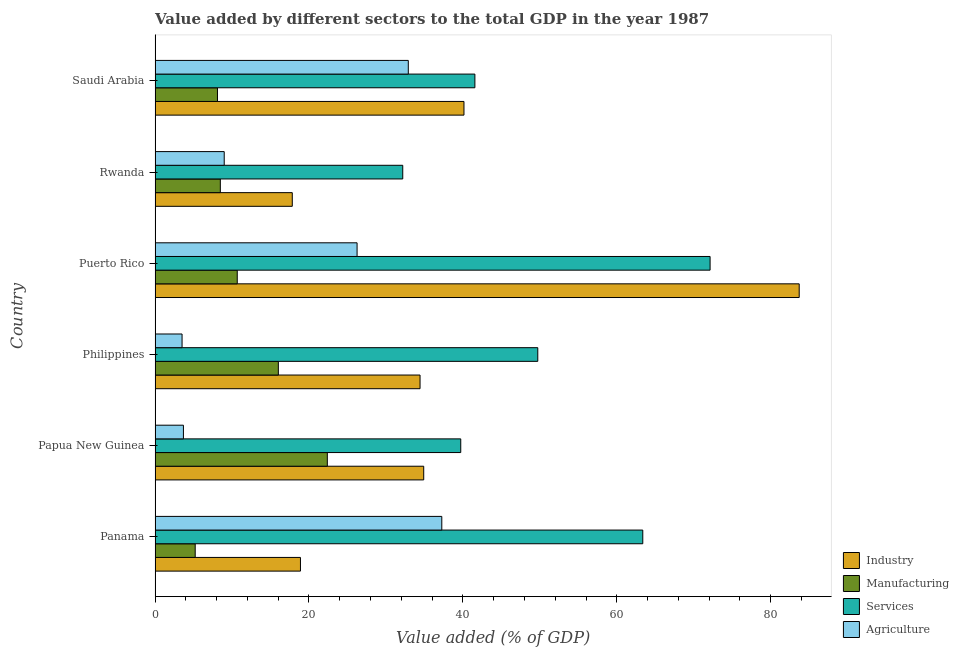How many bars are there on the 2nd tick from the top?
Provide a succinct answer. 4. How many bars are there on the 4th tick from the bottom?
Your answer should be very brief. 4. What is the label of the 3rd group of bars from the top?
Give a very brief answer. Puerto Rico. What is the value added by manufacturing sector in Philippines?
Give a very brief answer. 16.02. Across all countries, what is the maximum value added by industrial sector?
Provide a succinct answer. 83.7. Across all countries, what is the minimum value added by manufacturing sector?
Your response must be concise. 5.22. In which country was the value added by manufacturing sector maximum?
Keep it short and to the point. Papua New Guinea. In which country was the value added by manufacturing sector minimum?
Keep it short and to the point. Panama. What is the total value added by industrial sector in the graph?
Your answer should be compact. 229.91. What is the difference between the value added by services sector in Rwanda and that in Saudi Arabia?
Offer a very short reply. -9.37. What is the difference between the value added by services sector in Puerto Rico and the value added by agricultural sector in Rwanda?
Offer a terse response. 63.13. What is the average value added by manufacturing sector per country?
Give a very brief answer. 11.81. What is the difference between the value added by manufacturing sector and value added by industrial sector in Rwanda?
Provide a short and direct response. -9.35. What is the ratio of the value added by manufacturing sector in Philippines to that in Puerto Rico?
Keep it short and to the point. 1.5. Is the value added by agricultural sector in Papua New Guinea less than that in Rwanda?
Your answer should be very brief. Yes. What is the difference between the highest and the second highest value added by industrial sector?
Keep it short and to the point. 43.56. What is the difference between the highest and the lowest value added by industrial sector?
Provide a short and direct response. 65.87. Is the sum of the value added by agricultural sector in Papua New Guinea and Puerto Rico greater than the maximum value added by industrial sector across all countries?
Your response must be concise. No. Is it the case that in every country, the sum of the value added by services sector and value added by manufacturing sector is greater than the sum of value added by industrial sector and value added by agricultural sector?
Offer a very short reply. No. What does the 4th bar from the top in Philippines represents?
Offer a very short reply. Industry. What does the 4th bar from the bottom in Panama represents?
Offer a very short reply. Agriculture. How many bars are there?
Your answer should be compact. 24. Are all the bars in the graph horizontal?
Your answer should be compact. Yes. Are the values on the major ticks of X-axis written in scientific E-notation?
Ensure brevity in your answer.  No. Does the graph contain any zero values?
Keep it short and to the point. No. How many legend labels are there?
Offer a very short reply. 4. How are the legend labels stacked?
Keep it short and to the point. Vertical. What is the title of the graph?
Keep it short and to the point. Value added by different sectors to the total GDP in the year 1987. Does "Pre-primary schools" appear as one of the legend labels in the graph?
Your answer should be very brief. No. What is the label or title of the X-axis?
Provide a succinct answer. Value added (% of GDP). What is the Value added (% of GDP) of Industry in Panama?
Your answer should be compact. 18.89. What is the Value added (% of GDP) of Manufacturing in Panama?
Ensure brevity in your answer.  5.22. What is the Value added (% of GDP) in Services in Panama?
Provide a succinct answer. 63.38. What is the Value added (% of GDP) of Agriculture in Panama?
Provide a succinct answer. 37.26. What is the Value added (% of GDP) in Industry in Papua New Guinea?
Your response must be concise. 34.91. What is the Value added (% of GDP) in Manufacturing in Papua New Guinea?
Your answer should be very brief. 22.39. What is the Value added (% of GDP) of Services in Papua New Guinea?
Your answer should be very brief. 39.72. What is the Value added (% of GDP) of Agriculture in Papua New Guinea?
Offer a very short reply. 3.69. What is the Value added (% of GDP) in Industry in Philippines?
Keep it short and to the point. 34.43. What is the Value added (% of GDP) in Manufacturing in Philippines?
Offer a very short reply. 16.02. What is the Value added (% of GDP) of Services in Philippines?
Make the answer very short. 49.73. What is the Value added (% of GDP) of Agriculture in Philippines?
Offer a very short reply. 3.51. What is the Value added (% of GDP) in Industry in Puerto Rico?
Your answer should be compact. 83.7. What is the Value added (% of GDP) in Manufacturing in Puerto Rico?
Ensure brevity in your answer.  10.68. What is the Value added (% of GDP) in Services in Puerto Rico?
Keep it short and to the point. 72.12. What is the Value added (% of GDP) in Agriculture in Puerto Rico?
Offer a very short reply. 26.25. What is the Value added (% of GDP) of Industry in Rwanda?
Your answer should be very brief. 17.83. What is the Value added (% of GDP) of Manufacturing in Rwanda?
Offer a terse response. 8.48. What is the Value added (% of GDP) of Services in Rwanda?
Give a very brief answer. 32.18. What is the Value added (% of GDP) of Agriculture in Rwanda?
Make the answer very short. 8.99. What is the Value added (% of GDP) of Industry in Saudi Arabia?
Keep it short and to the point. 40.14. What is the Value added (% of GDP) of Manufacturing in Saudi Arabia?
Give a very brief answer. 8.11. What is the Value added (% of GDP) of Services in Saudi Arabia?
Provide a short and direct response. 41.56. What is the Value added (% of GDP) of Agriculture in Saudi Arabia?
Make the answer very short. 32.91. Across all countries, what is the maximum Value added (% of GDP) in Industry?
Your answer should be very brief. 83.7. Across all countries, what is the maximum Value added (% of GDP) in Manufacturing?
Keep it short and to the point. 22.39. Across all countries, what is the maximum Value added (% of GDP) in Services?
Your response must be concise. 72.12. Across all countries, what is the maximum Value added (% of GDP) in Agriculture?
Give a very brief answer. 37.26. Across all countries, what is the minimum Value added (% of GDP) in Industry?
Offer a very short reply. 17.83. Across all countries, what is the minimum Value added (% of GDP) of Manufacturing?
Your answer should be compact. 5.22. Across all countries, what is the minimum Value added (% of GDP) of Services?
Give a very brief answer. 32.18. Across all countries, what is the minimum Value added (% of GDP) in Agriculture?
Offer a terse response. 3.51. What is the total Value added (% of GDP) of Industry in the graph?
Your response must be concise. 229.91. What is the total Value added (% of GDP) in Manufacturing in the graph?
Offer a terse response. 70.89. What is the total Value added (% of GDP) of Services in the graph?
Ensure brevity in your answer.  298.69. What is the total Value added (% of GDP) in Agriculture in the graph?
Your answer should be compact. 112.6. What is the difference between the Value added (% of GDP) in Industry in Panama and that in Papua New Guinea?
Give a very brief answer. -16.02. What is the difference between the Value added (% of GDP) of Manufacturing in Panama and that in Papua New Guinea?
Give a very brief answer. -17.17. What is the difference between the Value added (% of GDP) in Services in Panama and that in Papua New Guinea?
Offer a terse response. 23.65. What is the difference between the Value added (% of GDP) in Agriculture in Panama and that in Papua New Guinea?
Give a very brief answer. 33.57. What is the difference between the Value added (% of GDP) in Industry in Panama and that in Philippines?
Make the answer very short. -15.54. What is the difference between the Value added (% of GDP) of Manufacturing in Panama and that in Philippines?
Provide a short and direct response. -10.8. What is the difference between the Value added (% of GDP) in Services in Panama and that in Philippines?
Your response must be concise. 13.64. What is the difference between the Value added (% of GDP) of Agriculture in Panama and that in Philippines?
Your answer should be compact. 33.75. What is the difference between the Value added (% of GDP) in Industry in Panama and that in Puerto Rico?
Your answer should be compact. -64.81. What is the difference between the Value added (% of GDP) in Manufacturing in Panama and that in Puerto Rico?
Offer a very short reply. -5.46. What is the difference between the Value added (% of GDP) in Services in Panama and that in Puerto Rico?
Your response must be concise. -8.75. What is the difference between the Value added (% of GDP) of Agriculture in Panama and that in Puerto Rico?
Provide a succinct answer. 11.01. What is the difference between the Value added (% of GDP) in Industry in Panama and that in Rwanda?
Give a very brief answer. 1.06. What is the difference between the Value added (% of GDP) in Manufacturing in Panama and that in Rwanda?
Offer a very short reply. -3.26. What is the difference between the Value added (% of GDP) of Services in Panama and that in Rwanda?
Offer a very short reply. 31.19. What is the difference between the Value added (% of GDP) of Agriculture in Panama and that in Rwanda?
Your response must be concise. 28.27. What is the difference between the Value added (% of GDP) of Industry in Panama and that in Saudi Arabia?
Keep it short and to the point. -21.25. What is the difference between the Value added (% of GDP) in Manufacturing in Panama and that in Saudi Arabia?
Offer a very short reply. -2.89. What is the difference between the Value added (% of GDP) in Services in Panama and that in Saudi Arabia?
Give a very brief answer. 21.82. What is the difference between the Value added (% of GDP) in Agriculture in Panama and that in Saudi Arabia?
Provide a short and direct response. 4.35. What is the difference between the Value added (% of GDP) of Industry in Papua New Guinea and that in Philippines?
Offer a terse response. 0.48. What is the difference between the Value added (% of GDP) in Manufacturing in Papua New Guinea and that in Philippines?
Offer a terse response. 6.37. What is the difference between the Value added (% of GDP) of Services in Papua New Guinea and that in Philippines?
Offer a very short reply. -10.01. What is the difference between the Value added (% of GDP) in Agriculture in Papua New Guinea and that in Philippines?
Keep it short and to the point. 0.18. What is the difference between the Value added (% of GDP) of Industry in Papua New Guinea and that in Puerto Rico?
Give a very brief answer. -48.79. What is the difference between the Value added (% of GDP) of Manufacturing in Papua New Guinea and that in Puerto Rico?
Offer a terse response. 11.71. What is the difference between the Value added (% of GDP) of Services in Papua New Guinea and that in Puerto Rico?
Keep it short and to the point. -32.4. What is the difference between the Value added (% of GDP) in Agriculture in Papua New Guinea and that in Puerto Rico?
Offer a terse response. -22.56. What is the difference between the Value added (% of GDP) in Industry in Papua New Guinea and that in Rwanda?
Provide a short and direct response. 17.08. What is the difference between the Value added (% of GDP) of Manufacturing in Papua New Guinea and that in Rwanda?
Your answer should be compact. 13.9. What is the difference between the Value added (% of GDP) of Services in Papua New Guinea and that in Rwanda?
Offer a terse response. 7.54. What is the difference between the Value added (% of GDP) in Agriculture in Papua New Guinea and that in Rwanda?
Your answer should be compact. -5.3. What is the difference between the Value added (% of GDP) of Industry in Papua New Guinea and that in Saudi Arabia?
Your response must be concise. -5.23. What is the difference between the Value added (% of GDP) of Manufacturing in Papua New Guinea and that in Saudi Arabia?
Give a very brief answer. 14.27. What is the difference between the Value added (% of GDP) in Services in Papua New Guinea and that in Saudi Arabia?
Provide a short and direct response. -1.84. What is the difference between the Value added (% of GDP) in Agriculture in Papua New Guinea and that in Saudi Arabia?
Offer a terse response. -29.22. What is the difference between the Value added (% of GDP) of Industry in Philippines and that in Puerto Rico?
Your response must be concise. -49.27. What is the difference between the Value added (% of GDP) of Manufacturing in Philippines and that in Puerto Rico?
Ensure brevity in your answer.  5.34. What is the difference between the Value added (% of GDP) of Services in Philippines and that in Puerto Rico?
Your answer should be compact. -22.39. What is the difference between the Value added (% of GDP) in Agriculture in Philippines and that in Puerto Rico?
Give a very brief answer. -22.74. What is the difference between the Value added (% of GDP) of Industry in Philippines and that in Rwanda?
Make the answer very short. 16.6. What is the difference between the Value added (% of GDP) in Manufacturing in Philippines and that in Rwanda?
Make the answer very short. 7.54. What is the difference between the Value added (% of GDP) in Services in Philippines and that in Rwanda?
Make the answer very short. 17.55. What is the difference between the Value added (% of GDP) of Agriculture in Philippines and that in Rwanda?
Your response must be concise. -5.48. What is the difference between the Value added (% of GDP) in Industry in Philippines and that in Saudi Arabia?
Provide a short and direct response. -5.71. What is the difference between the Value added (% of GDP) in Manufacturing in Philippines and that in Saudi Arabia?
Keep it short and to the point. 7.91. What is the difference between the Value added (% of GDP) in Services in Philippines and that in Saudi Arabia?
Offer a terse response. 8.17. What is the difference between the Value added (% of GDP) in Agriculture in Philippines and that in Saudi Arabia?
Make the answer very short. -29.4. What is the difference between the Value added (% of GDP) in Industry in Puerto Rico and that in Rwanda?
Provide a succinct answer. 65.87. What is the difference between the Value added (% of GDP) in Manufacturing in Puerto Rico and that in Rwanda?
Provide a succinct answer. 2.2. What is the difference between the Value added (% of GDP) of Services in Puerto Rico and that in Rwanda?
Your answer should be very brief. 39.94. What is the difference between the Value added (% of GDP) of Agriculture in Puerto Rico and that in Rwanda?
Make the answer very short. 17.26. What is the difference between the Value added (% of GDP) in Industry in Puerto Rico and that in Saudi Arabia?
Give a very brief answer. 43.56. What is the difference between the Value added (% of GDP) in Manufacturing in Puerto Rico and that in Saudi Arabia?
Provide a short and direct response. 2.57. What is the difference between the Value added (% of GDP) in Services in Puerto Rico and that in Saudi Arabia?
Offer a terse response. 30.56. What is the difference between the Value added (% of GDP) of Agriculture in Puerto Rico and that in Saudi Arabia?
Offer a very short reply. -6.66. What is the difference between the Value added (% of GDP) in Industry in Rwanda and that in Saudi Arabia?
Provide a short and direct response. -22.31. What is the difference between the Value added (% of GDP) in Manufacturing in Rwanda and that in Saudi Arabia?
Make the answer very short. 0.37. What is the difference between the Value added (% of GDP) in Services in Rwanda and that in Saudi Arabia?
Offer a terse response. -9.37. What is the difference between the Value added (% of GDP) of Agriculture in Rwanda and that in Saudi Arabia?
Provide a short and direct response. -23.92. What is the difference between the Value added (% of GDP) of Industry in Panama and the Value added (% of GDP) of Manufacturing in Papua New Guinea?
Provide a short and direct response. -3.49. What is the difference between the Value added (% of GDP) in Industry in Panama and the Value added (% of GDP) in Services in Papua New Guinea?
Your answer should be compact. -20.83. What is the difference between the Value added (% of GDP) of Industry in Panama and the Value added (% of GDP) of Agriculture in Papua New Guinea?
Offer a very short reply. 15.21. What is the difference between the Value added (% of GDP) of Manufacturing in Panama and the Value added (% of GDP) of Services in Papua New Guinea?
Ensure brevity in your answer.  -34.51. What is the difference between the Value added (% of GDP) of Manufacturing in Panama and the Value added (% of GDP) of Agriculture in Papua New Guinea?
Ensure brevity in your answer.  1.53. What is the difference between the Value added (% of GDP) of Services in Panama and the Value added (% of GDP) of Agriculture in Papua New Guinea?
Ensure brevity in your answer.  59.69. What is the difference between the Value added (% of GDP) of Industry in Panama and the Value added (% of GDP) of Manufacturing in Philippines?
Provide a short and direct response. 2.87. What is the difference between the Value added (% of GDP) in Industry in Panama and the Value added (% of GDP) in Services in Philippines?
Your response must be concise. -30.84. What is the difference between the Value added (% of GDP) of Industry in Panama and the Value added (% of GDP) of Agriculture in Philippines?
Keep it short and to the point. 15.38. What is the difference between the Value added (% of GDP) of Manufacturing in Panama and the Value added (% of GDP) of Services in Philippines?
Make the answer very short. -44.52. What is the difference between the Value added (% of GDP) in Manufacturing in Panama and the Value added (% of GDP) in Agriculture in Philippines?
Your answer should be very brief. 1.71. What is the difference between the Value added (% of GDP) of Services in Panama and the Value added (% of GDP) of Agriculture in Philippines?
Offer a terse response. 59.87. What is the difference between the Value added (% of GDP) of Industry in Panama and the Value added (% of GDP) of Manufacturing in Puerto Rico?
Offer a very short reply. 8.21. What is the difference between the Value added (% of GDP) in Industry in Panama and the Value added (% of GDP) in Services in Puerto Rico?
Keep it short and to the point. -53.23. What is the difference between the Value added (% of GDP) in Industry in Panama and the Value added (% of GDP) in Agriculture in Puerto Rico?
Keep it short and to the point. -7.36. What is the difference between the Value added (% of GDP) in Manufacturing in Panama and the Value added (% of GDP) in Services in Puerto Rico?
Provide a succinct answer. -66.91. What is the difference between the Value added (% of GDP) of Manufacturing in Panama and the Value added (% of GDP) of Agriculture in Puerto Rico?
Provide a short and direct response. -21.03. What is the difference between the Value added (% of GDP) in Services in Panama and the Value added (% of GDP) in Agriculture in Puerto Rico?
Provide a short and direct response. 37.13. What is the difference between the Value added (% of GDP) in Industry in Panama and the Value added (% of GDP) in Manufacturing in Rwanda?
Ensure brevity in your answer.  10.41. What is the difference between the Value added (% of GDP) of Industry in Panama and the Value added (% of GDP) of Services in Rwanda?
Give a very brief answer. -13.29. What is the difference between the Value added (% of GDP) of Industry in Panama and the Value added (% of GDP) of Agriculture in Rwanda?
Keep it short and to the point. 9.91. What is the difference between the Value added (% of GDP) in Manufacturing in Panama and the Value added (% of GDP) in Services in Rwanda?
Your answer should be very brief. -26.97. What is the difference between the Value added (% of GDP) of Manufacturing in Panama and the Value added (% of GDP) of Agriculture in Rwanda?
Make the answer very short. -3.77. What is the difference between the Value added (% of GDP) in Services in Panama and the Value added (% of GDP) in Agriculture in Rwanda?
Provide a succinct answer. 54.39. What is the difference between the Value added (% of GDP) in Industry in Panama and the Value added (% of GDP) in Manufacturing in Saudi Arabia?
Your response must be concise. 10.78. What is the difference between the Value added (% of GDP) in Industry in Panama and the Value added (% of GDP) in Services in Saudi Arabia?
Your response must be concise. -22.67. What is the difference between the Value added (% of GDP) of Industry in Panama and the Value added (% of GDP) of Agriculture in Saudi Arabia?
Your answer should be very brief. -14.01. What is the difference between the Value added (% of GDP) of Manufacturing in Panama and the Value added (% of GDP) of Services in Saudi Arabia?
Offer a very short reply. -36.34. What is the difference between the Value added (% of GDP) in Manufacturing in Panama and the Value added (% of GDP) in Agriculture in Saudi Arabia?
Give a very brief answer. -27.69. What is the difference between the Value added (% of GDP) in Services in Panama and the Value added (% of GDP) in Agriculture in Saudi Arabia?
Your answer should be compact. 30.47. What is the difference between the Value added (% of GDP) of Industry in Papua New Guinea and the Value added (% of GDP) of Manufacturing in Philippines?
Provide a succinct answer. 18.89. What is the difference between the Value added (% of GDP) of Industry in Papua New Guinea and the Value added (% of GDP) of Services in Philippines?
Provide a short and direct response. -14.82. What is the difference between the Value added (% of GDP) in Industry in Papua New Guinea and the Value added (% of GDP) in Agriculture in Philippines?
Keep it short and to the point. 31.4. What is the difference between the Value added (% of GDP) of Manufacturing in Papua New Guinea and the Value added (% of GDP) of Services in Philippines?
Give a very brief answer. -27.35. What is the difference between the Value added (% of GDP) of Manufacturing in Papua New Guinea and the Value added (% of GDP) of Agriculture in Philippines?
Ensure brevity in your answer.  18.88. What is the difference between the Value added (% of GDP) in Services in Papua New Guinea and the Value added (% of GDP) in Agriculture in Philippines?
Ensure brevity in your answer.  36.21. What is the difference between the Value added (% of GDP) in Industry in Papua New Guinea and the Value added (% of GDP) in Manufacturing in Puerto Rico?
Offer a very short reply. 24.23. What is the difference between the Value added (% of GDP) of Industry in Papua New Guinea and the Value added (% of GDP) of Services in Puerto Rico?
Provide a short and direct response. -37.21. What is the difference between the Value added (% of GDP) of Industry in Papua New Guinea and the Value added (% of GDP) of Agriculture in Puerto Rico?
Offer a very short reply. 8.66. What is the difference between the Value added (% of GDP) of Manufacturing in Papua New Guinea and the Value added (% of GDP) of Services in Puerto Rico?
Your answer should be very brief. -49.74. What is the difference between the Value added (% of GDP) in Manufacturing in Papua New Guinea and the Value added (% of GDP) in Agriculture in Puerto Rico?
Provide a short and direct response. -3.86. What is the difference between the Value added (% of GDP) of Services in Papua New Guinea and the Value added (% of GDP) of Agriculture in Puerto Rico?
Offer a very short reply. 13.47. What is the difference between the Value added (% of GDP) in Industry in Papua New Guinea and the Value added (% of GDP) in Manufacturing in Rwanda?
Provide a succinct answer. 26.43. What is the difference between the Value added (% of GDP) in Industry in Papua New Guinea and the Value added (% of GDP) in Services in Rwanda?
Make the answer very short. 2.73. What is the difference between the Value added (% of GDP) of Industry in Papua New Guinea and the Value added (% of GDP) of Agriculture in Rwanda?
Your response must be concise. 25.92. What is the difference between the Value added (% of GDP) in Manufacturing in Papua New Guinea and the Value added (% of GDP) in Services in Rwanda?
Ensure brevity in your answer.  -9.8. What is the difference between the Value added (% of GDP) of Manufacturing in Papua New Guinea and the Value added (% of GDP) of Agriculture in Rwanda?
Give a very brief answer. 13.4. What is the difference between the Value added (% of GDP) in Services in Papua New Guinea and the Value added (% of GDP) in Agriculture in Rwanda?
Give a very brief answer. 30.73. What is the difference between the Value added (% of GDP) of Industry in Papua New Guinea and the Value added (% of GDP) of Manufacturing in Saudi Arabia?
Ensure brevity in your answer.  26.8. What is the difference between the Value added (% of GDP) in Industry in Papua New Guinea and the Value added (% of GDP) in Services in Saudi Arabia?
Your response must be concise. -6.65. What is the difference between the Value added (% of GDP) of Industry in Papua New Guinea and the Value added (% of GDP) of Agriculture in Saudi Arabia?
Your answer should be compact. 2. What is the difference between the Value added (% of GDP) in Manufacturing in Papua New Guinea and the Value added (% of GDP) in Services in Saudi Arabia?
Keep it short and to the point. -19.17. What is the difference between the Value added (% of GDP) of Manufacturing in Papua New Guinea and the Value added (% of GDP) of Agriculture in Saudi Arabia?
Give a very brief answer. -10.52. What is the difference between the Value added (% of GDP) in Services in Papua New Guinea and the Value added (% of GDP) in Agriculture in Saudi Arabia?
Provide a short and direct response. 6.82. What is the difference between the Value added (% of GDP) in Industry in Philippines and the Value added (% of GDP) in Manufacturing in Puerto Rico?
Keep it short and to the point. 23.75. What is the difference between the Value added (% of GDP) in Industry in Philippines and the Value added (% of GDP) in Services in Puerto Rico?
Your answer should be very brief. -37.69. What is the difference between the Value added (% of GDP) of Industry in Philippines and the Value added (% of GDP) of Agriculture in Puerto Rico?
Provide a succinct answer. 8.18. What is the difference between the Value added (% of GDP) of Manufacturing in Philippines and the Value added (% of GDP) of Services in Puerto Rico?
Your answer should be very brief. -56.1. What is the difference between the Value added (% of GDP) of Manufacturing in Philippines and the Value added (% of GDP) of Agriculture in Puerto Rico?
Offer a very short reply. -10.23. What is the difference between the Value added (% of GDP) of Services in Philippines and the Value added (% of GDP) of Agriculture in Puerto Rico?
Offer a terse response. 23.48. What is the difference between the Value added (% of GDP) of Industry in Philippines and the Value added (% of GDP) of Manufacturing in Rwanda?
Keep it short and to the point. 25.95. What is the difference between the Value added (% of GDP) in Industry in Philippines and the Value added (% of GDP) in Services in Rwanda?
Your response must be concise. 2.25. What is the difference between the Value added (% of GDP) in Industry in Philippines and the Value added (% of GDP) in Agriculture in Rwanda?
Make the answer very short. 25.45. What is the difference between the Value added (% of GDP) of Manufacturing in Philippines and the Value added (% of GDP) of Services in Rwanda?
Your answer should be very brief. -16.17. What is the difference between the Value added (% of GDP) of Manufacturing in Philippines and the Value added (% of GDP) of Agriculture in Rwanda?
Give a very brief answer. 7.03. What is the difference between the Value added (% of GDP) in Services in Philippines and the Value added (% of GDP) in Agriculture in Rwanda?
Provide a succinct answer. 40.74. What is the difference between the Value added (% of GDP) of Industry in Philippines and the Value added (% of GDP) of Manufacturing in Saudi Arabia?
Your answer should be compact. 26.32. What is the difference between the Value added (% of GDP) in Industry in Philippines and the Value added (% of GDP) in Services in Saudi Arabia?
Ensure brevity in your answer.  -7.13. What is the difference between the Value added (% of GDP) in Industry in Philippines and the Value added (% of GDP) in Agriculture in Saudi Arabia?
Offer a terse response. 1.53. What is the difference between the Value added (% of GDP) in Manufacturing in Philippines and the Value added (% of GDP) in Services in Saudi Arabia?
Ensure brevity in your answer.  -25.54. What is the difference between the Value added (% of GDP) in Manufacturing in Philippines and the Value added (% of GDP) in Agriculture in Saudi Arabia?
Ensure brevity in your answer.  -16.89. What is the difference between the Value added (% of GDP) of Services in Philippines and the Value added (% of GDP) of Agriculture in Saudi Arabia?
Offer a terse response. 16.83. What is the difference between the Value added (% of GDP) of Industry in Puerto Rico and the Value added (% of GDP) of Manufacturing in Rwanda?
Your answer should be very brief. 75.22. What is the difference between the Value added (% of GDP) of Industry in Puerto Rico and the Value added (% of GDP) of Services in Rwanda?
Keep it short and to the point. 51.52. What is the difference between the Value added (% of GDP) in Industry in Puerto Rico and the Value added (% of GDP) in Agriculture in Rwanda?
Your answer should be compact. 74.71. What is the difference between the Value added (% of GDP) of Manufacturing in Puerto Rico and the Value added (% of GDP) of Services in Rwanda?
Provide a short and direct response. -21.5. What is the difference between the Value added (% of GDP) in Manufacturing in Puerto Rico and the Value added (% of GDP) in Agriculture in Rwanda?
Provide a succinct answer. 1.69. What is the difference between the Value added (% of GDP) of Services in Puerto Rico and the Value added (% of GDP) of Agriculture in Rwanda?
Ensure brevity in your answer.  63.13. What is the difference between the Value added (% of GDP) in Industry in Puerto Rico and the Value added (% of GDP) in Manufacturing in Saudi Arabia?
Provide a short and direct response. 75.59. What is the difference between the Value added (% of GDP) in Industry in Puerto Rico and the Value added (% of GDP) in Services in Saudi Arabia?
Your response must be concise. 42.14. What is the difference between the Value added (% of GDP) of Industry in Puerto Rico and the Value added (% of GDP) of Agriculture in Saudi Arabia?
Ensure brevity in your answer.  50.79. What is the difference between the Value added (% of GDP) of Manufacturing in Puerto Rico and the Value added (% of GDP) of Services in Saudi Arabia?
Offer a terse response. -30.88. What is the difference between the Value added (% of GDP) in Manufacturing in Puerto Rico and the Value added (% of GDP) in Agriculture in Saudi Arabia?
Make the answer very short. -22.23. What is the difference between the Value added (% of GDP) in Services in Puerto Rico and the Value added (% of GDP) in Agriculture in Saudi Arabia?
Provide a short and direct response. 39.22. What is the difference between the Value added (% of GDP) in Industry in Rwanda and the Value added (% of GDP) in Manufacturing in Saudi Arabia?
Your answer should be compact. 9.72. What is the difference between the Value added (% of GDP) of Industry in Rwanda and the Value added (% of GDP) of Services in Saudi Arabia?
Your answer should be very brief. -23.73. What is the difference between the Value added (% of GDP) of Industry in Rwanda and the Value added (% of GDP) of Agriculture in Saudi Arabia?
Provide a succinct answer. -15.07. What is the difference between the Value added (% of GDP) in Manufacturing in Rwanda and the Value added (% of GDP) in Services in Saudi Arabia?
Ensure brevity in your answer.  -33.08. What is the difference between the Value added (% of GDP) of Manufacturing in Rwanda and the Value added (% of GDP) of Agriculture in Saudi Arabia?
Your answer should be compact. -24.43. What is the difference between the Value added (% of GDP) of Services in Rwanda and the Value added (% of GDP) of Agriculture in Saudi Arabia?
Your answer should be compact. -0.72. What is the average Value added (% of GDP) in Industry per country?
Make the answer very short. 38.32. What is the average Value added (% of GDP) in Manufacturing per country?
Offer a terse response. 11.81. What is the average Value added (% of GDP) in Services per country?
Provide a short and direct response. 49.78. What is the average Value added (% of GDP) in Agriculture per country?
Offer a terse response. 18.77. What is the difference between the Value added (% of GDP) in Industry and Value added (% of GDP) in Manufacturing in Panama?
Offer a terse response. 13.68. What is the difference between the Value added (% of GDP) of Industry and Value added (% of GDP) of Services in Panama?
Give a very brief answer. -44.48. What is the difference between the Value added (% of GDP) of Industry and Value added (% of GDP) of Agriculture in Panama?
Your answer should be compact. -18.37. What is the difference between the Value added (% of GDP) in Manufacturing and Value added (% of GDP) in Services in Panama?
Provide a succinct answer. -58.16. What is the difference between the Value added (% of GDP) of Manufacturing and Value added (% of GDP) of Agriculture in Panama?
Make the answer very short. -32.04. What is the difference between the Value added (% of GDP) in Services and Value added (% of GDP) in Agriculture in Panama?
Your answer should be compact. 26.12. What is the difference between the Value added (% of GDP) of Industry and Value added (% of GDP) of Manufacturing in Papua New Guinea?
Offer a terse response. 12.52. What is the difference between the Value added (% of GDP) of Industry and Value added (% of GDP) of Services in Papua New Guinea?
Give a very brief answer. -4.81. What is the difference between the Value added (% of GDP) in Industry and Value added (% of GDP) in Agriculture in Papua New Guinea?
Ensure brevity in your answer.  31.22. What is the difference between the Value added (% of GDP) in Manufacturing and Value added (% of GDP) in Services in Papua New Guinea?
Keep it short and to the point. -17.34. What is the difference between the Value added (% of GDP) of Manufacturing and Value added (% of GDP) of Agriculture in Papua New Guinea?
Make the answer very short. 18.7. What is the difference between the Value added (% of GDP) in Services and Value added (% of GDP) in Agriculture in Papua New Guinea?
Offer a terse response. 36.04. What is the difference between the Value added (% of GDP) in Industry and Value added (% of GDP) in Manufacturing in Philippines?
Give a very brief answer. 18.41. What is the difference between the Value added (% of GDP) of Industry and Value added (% of GDP) of Services in Philippines?
Ensure brevity in your answer.  -15.3. What is the difference between the Value added (% of GDP) of Industry and Value added (% of GDP) of Agriculture in Philippines?
Your answer should be compact. 30.92. What is the difference between the Value added (% of GDP) in Manufacturing and Value added (% of GDP) in Services in Philippines?
Make the answer very short. -33.71. What is the difference between the Value added (% of GDP) in Manufacturing and Value added (% of GDP) in Agriculture in Philippines?
Provide a succinct answer. 12.51. What is the difference between the Value added (% of GDP) of Services and Value added (% of GDP) of Agriculture in Philippines?
Offer a very short reply. 46.22. What is the difference between the Value added (% of GDP) in Industry and Value added (% of GDP) in Manufacturing in Puerto Rico?
Your answer should be very brief. 73.02. What is the difference between the Value added (% of GDP) in Industry and Value added (% of GDP) in Services in Puerto Rico?
Ensure brevity in your answer.  11.58. What is the difference between the Value added (% of GDP) in Industry and Value added (% of GDP) in Agriculture in Puerto Rico?
Ensure brevity in your answer.  57.45. What is the difference between the Value added (% of GDP) in Manufacturing and Value added (% of GDP) in Services in Puerto Rico?
Ensure brevity in your answer.  -61.44. What is the difference between the Value added (% of GDP) of Manufacturing and Value added (% of GDP) of Agriculture in Puerto Rico?
Offer a terse response. -15.57. What is the difference between the Value added (% of GDP) in Services and Value added (% of GDP) in Agriculture in Puerto Rico?
Give a very brief answer. 45.87. What is the difference between the Value added (% of GDP) in Industry and Value added (% of GDP) in Manufacturing in Rwanda?
Your answer should be compact. 9.35. What is the difference between the Value added (% of GDP) of Industry and Value added (% of GDP) of Services in Rwanda?
Make the answer very short. -14.35. What is the difference between the Value added (% of GDP) in Industry and Value added (% of GDP) in Agriculture in Rwanda?
Give a very brief answer. 8.84. What is the difference between the Value added (% of GDP) in Manufacturing and Value added (% of GDP) in Services in Rwanda?
Offer a terse response. -23.7. What is the difference between the Value added (% of GDP) in Manufacturing and Value added (% of GDP) in Agriculture in Rwanda?
Provide a succinct answer. -0.51. What is the difference between the Value added (% of GDP) of Services and Value added (% of GDP) of Agriculture in Rwanda?
Ensure brevity in your answer.  23.2. What is the difference between the Value added (% of GDP) of Industry and Value added (% of GDP) of Manufacturing in Saudi Arabia?
Your answer should be very brief. 32.03. What is the difference between the Value added (% of GDP) in Industry and Value added (% of GDP) in Services in Saudi Arabia?
Your answer should be very brief. -1.42. What is the difference between the Value added (% of GDP) in Industry and Value added (% of GDP) in Agriculture in Saudi Arabia?
Keep it short and to the point. 7.23. What is the difference between the Value added (% of GDP) of Manufacturing and Value added (% of GDP) of Services in Saudi Arabia?
Offer a terse response. -33.45. What is the difference between the Value added (% of GDP) of Manufacturing and Value added (% of GDP) of Agriculture in Saudi Arabia?
Provide a succinct answer. -24.8. What is the difference between the Value added (% of GDP) of Services and Value added (% of GDP) of Agriculture in Saudi Arabia?
Provide a short and direct response. 8.65. What is the ratio of the Value added (% of GDP) of Industry in Panama to that in Papua New Guinea?
Your response must be concise. 0.54. What is the ratio of the Value added (% of GDP) of Manufacturing in Panama to that in Papua New Guinea?
Your answer should be very brief. 0.23. What is the ratio of the Value added (% of GDP) in Services in Panama to that in Papua New Guinea?
Your response must be concise. 1.6. What is the ratio of the Value added (% of GDP) of Agriculture in Panama to that in Papua New Guinea?
Your response must be concise. 10.11. What is the ratio of the Value added (% of GDP) of Industry in Panama to that in Philippines?
Make the answer very short. 0.55. What is the ratio of the Value added (% of GDP) in Manufacturing in Panama to that in Philippines?
Ensure brevity in your answer.  0.33. What is the ratio of the Value added (% of GDP) in Services in Panama to that in Philippines?
Give a very brief answer. 1.27. What is the ratio of the Value added (% of GDP) in Agriculture in Panama to that in Philippines?
Offer a terse response. 10.62. What is the ratio of the Value added (% of GDP) of Industry in Panama to that in Puerto Rico?
Give a very brief answer. 0.23. What is the ratio of the Value added (% of GDP) in Manufacturing in Panama to that in Puerto Rico?
Provide a succinct answer. 0.49. What is the ratio of the Value added (% of GDP) of Services in Panama to that in Puerto Rico?
Your response must be concise. 0.88. What is the ratio of the Value added (% of GDP) of Agriculture in Panama to that in Puerto Rico?
Ensure brevity in your answer.  1.42. What is the ratio of the Value added (% of GDP) of Industry in Panama to that in Rwanda?
Give a very brief answer. 1.06. What is the ratio of the Value added (% of GDP) in Manufacturing in Panama to that in Rwanda?
Provide a succinct answer. 0.61. What is the ratio of the Value added (% of GDP) of Services in Panama to that in Rwanda?
Your answer should be compact. 1.97. What is the ratio of the Value added (% of GDP) in Agriculture in Panama to that in Rwanda?
Your answer should be compact. 4.15. What is the ratio of the Value added (% of GDP) in Industry in Panama to that in Saudi Arabia?
Your answer should be very brief. 0.47. What is the ratio of the Value added (% of GDP) of Manufacturing in Panama to that in Saudi Arabia?
Keep it short and to the point. 0.64. What is the ratio of the Value added (% of GDP) in Services in Panama to that in Saudi Arabia?
Your answer should be compact. 1.52. What is the ratio of the Value added (% of GDP) in Agriculture in Panama to that in Saudi Arabia?
Your answer should be compact. 1.13. What is the ratio of the Value added (% of GDP) of Industry in Papua New Guinea to that in Philippines?
Offer a terse response. 1.01. What is the ratio of the Value added (% of GDP) of Manufacturing in Papua New Guinea to that in Philippines?
Provide a succinct answer. 1.4. What is the ratio of the Value added (% of GDP) in Services in Papua New Guinea to that in Philippines?
Ensure brevity in your answer.  0.8. What is the ratio of the Value added (% of GDP) in Agriculture in Papua New Guinea to that in Philippines?
Keep it short and to the point. 1.05. What is the ratio of the Value added (% of GDP) in Industry in Papua New Guinea to that in Puerto Rico?
Offer a terse response. 0.42. What is the ratio of the Value added (% of GDP) of Manufacturing in Papua New Guinea to that in Puerto Rico?
Offer a terse response. 2.1. What is the ratio of the Value added (% of GDP) of Services in Papua New Guinea to that in Puerto Rico?
Your answer should be very brief. 0.55. What is the ratio of the Value added (% of GDP) in Agriculture in Papua New Guinea to that in Puerto Rico?
Your answer should be very brief. 0.14. What is the ratio of the Value added (% of GDP) of Industry in Papua New Guinea to that in Rwanda?
Provide a short and direct response. 1.96. What is the ratio of the Value added (% of GDP) of Manufacturing in Papua New Guinea to that in Rwanda?
Provide a succinct answer. 2.64. What is the ratio of the Value added (% of GDP) in Services in Papua New Guinea to that in Rwanda?
Provide a short and direct response. 1.23. What is the ratio of the Value added (% of GDP) in Agriculture in Papua New Guinea to that in Rwanda?
Your answer should be very brief. 0.41. What is the ratio of the Value added (% of GDP) in Industry in Papua New Guinea to that in Saudi Arabia?
Your answer should be compact. 0.87. What is the ratio of the Value added (% of GDP) of Manufacturing in Papua New Guinea to that in Saudi Arabia?
Offer a very short reply. 2.76. What is the ratio of the Value added (% of GDP) of Services in Papua New Guinea to that in Saudi Arabia?
Provide a succinct answer. 0.96. What is the ratio of the Value added (% of GDP) in Agriculture in Papua New Guinea to that in Saudi Arabia?
Keep it short and to the point. 0.11. What is the ratio of the Value added (% of GDP) of Industry in Philippines to that in Puerto Rico?
Your answer should be very brief. 0.41. What is the ratio of the Value added (% of GDP) in Manufacturing in Philippines to that in Puerto Rico?
Ensure brevity in your answer.  1.5. What is the ratio of the Value added (% of GDP) of Services in Philippines to that in Puerto Rico?
Keep it short and to the point. 0.69. What is the ratio of the Value added (% of GDP) in Agriculture in Philippines to that in Puerto Rico?
Give a very brief answer. 0.13. What is the ratio of the Value added (% of GDP) in Industry in Philippines to that in Rwanda?
Your answer should be very brief. 1.93. What is the ratio of the Value added (% of GDP) of Manufacturing in Philippines to that in Rwanda?
Offer a terse response. 1.89. What is the ratio of the Value added (% of GDP) of Services in Philippines to that in Rwanda?
Offer a terse response. 1.55. What is the ratio of the Value added (% of GDP) in Agriculture in Philippines to that in Rwanda?
Your answer should be compact. 0.39. What is the ratio of the Value added (% of GDP) of Industry in Philippines to that in Saudi Arabia?
Your response must be concise. 0.86. What is the ratio of the Value added (% of GDP) of Manufacturing in Philippines to that in Saudi Arabia?
Give a very brief answer. 1.98. What is the ratio of the Value added (% of GDP) in Services in Philippines to that in Saudi Arabia?
Your answer should be compact. 1.2. What is the ratio of the Value added (% of GDP) in Agriculture in Philippines to that in Saudi Arabia?
Provide a short and direct response. 0.11. What is the ratio of the Value added (% of GDP) of Industry in Puerto Rico to that in Rwanda?
Offer a terse response. 4.69. What is the ratio of the Value added (% of GDP) in Manufacturing in Puerto Rico to that in Rwanda?
Offer a very short reply. 1.26. What is the ratio of the Value added (% of GDP) of Services in Puerto Rico to that in Rwanda?
Offer a very short reply. 2.24. What is the ratio of the Value added (% of GDP) in Agriculture in Puerto Rico to that in Rwanda?
Provide a short and direct response. 2.92. What is the ratio of the Value added (% of GDP) of Industry in Puerto Rico to that in Saudi Arabia?
Ensure brevity in your answer.  2.09. What is the ratio of the Value added (% of GDP) of Manufacturing in Puerto Rico to that in Saudi Arabia?
Your answer should be compact. 1.32. What is the ratio of the Value added (% of GDP) of Services in Puerto Rico to that in Saudi Arabia?
Provide a short and direct response. 1.74. What is the ratio of the Value added (% of GDP) of Agriculture in Puerto Rico to that in Saudi Arabia?
Give a very brief answer. 0.8. What is the ratio of the Value added (% of GDP) in Industry in Rwanda to that in Saudi Arabia?
Your answer should be compact. 0.44. What is the ratio of the Value added (% of GDP) of Manufacturing in Rwanda to that in Saudi Arabia?
Your response must be concise. 1.05. What is the ratio of the Value added (% of GDP) of Services in Rwanda to that in Saudi Arabia?
Provide a succinct answer. 0.77. What is the ratio of the Value added (% of GDP) in Agriculture in Rwanda to that in Saudi Arabia?
Give a very brief answer. 0.27. What is the difference between the highest and the second highest Value added (% of GDP) of Industry?
Keep it short and to the point. 43.56. What is the difference between the highest and the second highest Value added (% of GDP) of Manufacturing?
Your answer should be compact. 6.37. What is the difference between the highest and the second highest Value added (% of GDP) of Services?
Keep it short and to the point. 8.75. What is the difference between the highest and the second highest Value added (% of GDP) of Agriculture?
Your answer should be very brief. 4.35. What is the difference between the highest and the lowest Value added (% of GDP) of Industry?
Make the answer very short. 65.87. What is the difference between the highest and the lowest Value added (% of GDP) of Manufacturing?
Provide a succinct answer. 17.17. What is the difference between the highest and the lowest Value added (% of GDP) in Services?
Your answer should be very brief. 39.94. What is the difference between the highest and the lowest Value added (% of GDP) in Agriculture?
Ensure brevity in your answer.  33.75. 